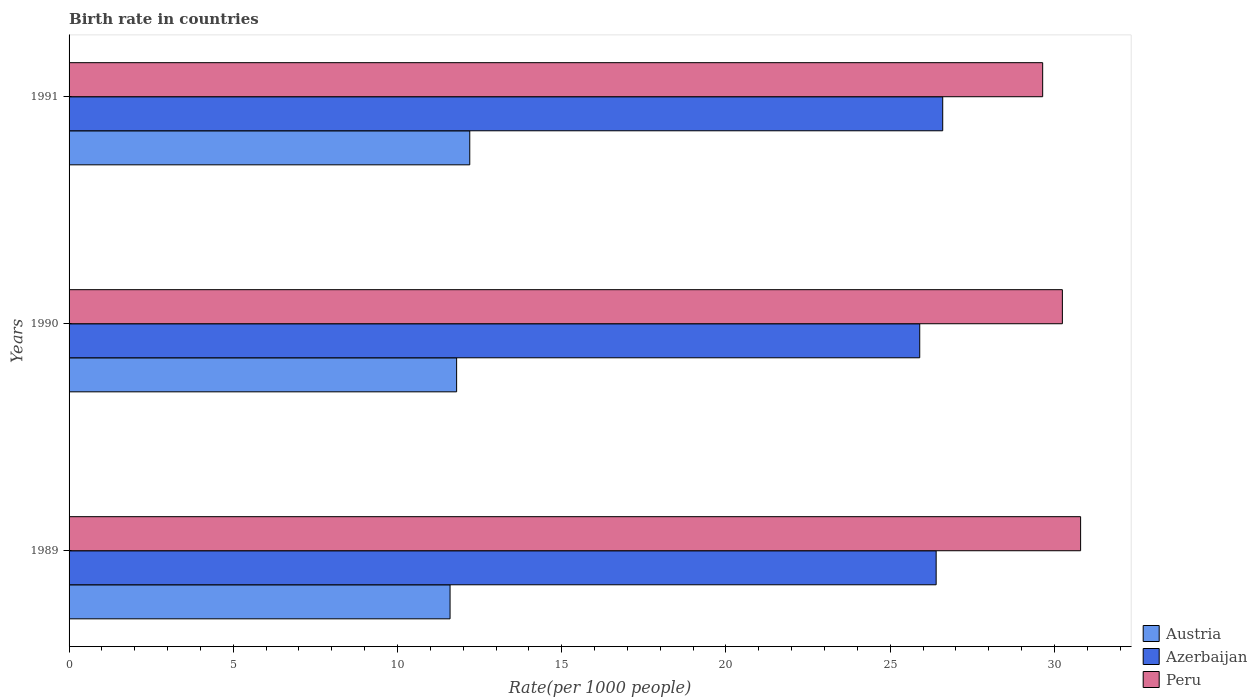How many different coloured bars are there?
Make the answer very short. 3. Are the number of bars per tick equal to the number of legend labels?
Offer a very short reply. Yes. How many bars are there on the 1st tick from the top?
Give a very brief answer. 3. How many bars are there on the 1st tick from the bottom?
Provide a short and direct response. 3. What is the label of the 1st group of bars from the top?
Your answer should be very brief. 1991. Across all years, what is the maximum birth rate in Peru?
Your response must be concise. 30.8. Across all years, what is the minimum birth rate in Azerbaijan?
Your answer should be very brief. 25.9. What is the total birth rate in Azerbaijan in the graph?
Keep it short and to the point. 78.9. What is the difference between the birth rate in Peru in 1990 and that in 1991?
Provide a succinct answer. 0.6. What is the difference between the birth rate in Azerbaijan in 1990 and the birth rate in Austria in 1991?
Provide a succinct answer. 13.7. What is the average birth rate in Austria per year?
Provide a short and direct response. 11.87. In the year 1990, what is the difference between the birth rate in Peru and birth rate in Azerbaijan?
Your answer should be very brief. 4.34. What is the ratio of the birth rate in Azerbaijan in 1989 to that in 1990?
Offer a terse response. 1.02. What is the difference between the highest and the second highest birth rate in Azerbaijan?
Your answer should be compact. 0.2. What is the difference between the highest and the lowest birth rate in Peru?
Provide a short and direct response. 1.15. Is the sum of the birth rate in Peru in 1989 and 1991 greater than the maximum birth rate in Azerbaijan across all years?
Your answer should be compact. Yes. Is it the case that in every year, the sum of the birth rate in Peru and birth rate in Austria is greater than the birth rate in Azerbaijan?
Your response must be concise. Yes. How many bars are there?
Provide a succinct answer. 9. Are all the bars in the graph horizontal?
Your answer should be very brief. Yes. What is the difference between two consecutive major ticks on the X-axis?
Your answer should be very brief. 5. Does the graph contain any zero values?
Your response must be concise. No. What is the title of the graph?
Offer a very short reply. Birth rate in countries. What is the label or title of the X-axis?
Your answer should be very brief. Rate(per 1000 people). What is the label or title of the Y-axis?
Your answer should be compact. Years. What is the Rate(per 1000 people) in Azerbaijan in 1989?
Provide a short and direct response. 26.4. What is the Rate(per 1000 people) of Peru in 1989?
Make the answer very short. 30.8. What is the Rate(per 1000 people) in Azerbaijan in 1990?
Give a very brief answer. 25.9. What is the Rate(per 1000 people) of Peru in 1990?
Offer a terse response. 30.24. What is the Rate(per 1000 people) in Austria in 1991?
Give a very brief answer. 12.2. What is the Rate(per 1000 people) in Azerbaijan in 1991?
Ensure brevity in your answer.  26.6. What is the Rate(per 1000 people) in Peru in 1991?
Make the answer very short. 29.64. Across all years, what is the maximum Rate(per 1000 people) of Austria?
Give a very brief answer. 12.2. Across all years, what is the maximum Rate(per 1000 people) in Azerbaijan?
Offer a terse response. 26.6. Across all years, what is the maximum Rate(per 1000 people) in Peru?
Provide a succinct answer. 30.8. Across all years, what is the minimum Rate(per 1000 people) of Azerbaijan?
Your answer should be very brief. 25.9. Across all years, what is the minimum Rate(per 1000 people) of Peru?
Your answer should be very brief. 29.64. What is the total Rate(per 1000 people) of Austria in the graph?
Your answer should be very brief. 35.6. What is the total Rate(per 1000 people) in Azerbaijan in the graph?
Provide a succinct answer. 78.9. What is the total Rate(per 1000 people) of Peru in the graph?
Your response must be concise. 90.68. What is the difference between the Rate(per 1000 people) in Austria in 1989 and that in 1990?
Give a very brief answer. -0.2. What is the difference between the Rate(per 1000 people) of Peru in 1989 and that in 1990?
Your response must be concise. 0.56. What is the difference between the Rate(per 1000 people) of Austria in 1989 and that in 1991?
Provide a short and direct response. -0.6. What is the difference between the Rate(per 1000 people) of Peru in 1989 and that in 1991?
Give a very brief answer. 1.16. What is the difference between the Rate(per 1000 people) of Azerbaijan in 1990 and that in 1991?
Ensure brevity in your answer.  -0.7. What is the difference between the Rate(per 1000 people) of Peru in 1990 and that in 1991?
Ensure brevity in your answer.  0.6. What is the difference between the Rate(per 1000 people) of Austria in 1989 and the Rate(per 1000 people) of Azerbaijan in 1990?
Your response must be concise. -14.3. What is the difference between the Rate(per 1000 people) in Austria in 1989 and the Rate(per 1000 people) in Peru in 1990?
Make the answer very short. -18.64. What is the difference between the Rate(per 1000 people) in Azerbaijan in 1989 and the Rate(per 1000 people) in Peru in 1990?
Your answer should be very brief. -3.84. What is the difference between the Rate(per 1000 people) in Austria in 1989 and the Rate(per 1000 people) in Azerbaijan in 1991?
Offer a very short reply. -15. What is the difference between the Rate(per 1000 people) of Austria in 1989 and the Rate(per 1000 people) of Peru in 1991?
Provide a succinct answer. -18.04. What is the difference between the Rate(per 1000 people) of Azerbaijan in 1989 and the Rate(per 1000 people) of Peru in 1991?
Make the answer very short. -3.24. What is the difference between the Rate(per 1000 people) of Austria in 1990 and the Rate(per 1000 people) of Azerbaijan in 1991?
Ensure brevity in your answer.  -14.8. What is the difference between the Rate(per 1000 people) of Austria in 1990 and the Rate(per 1000 people) of Peru in 1991?
Offer a very short reply. -17.84. What is the difference between the Rate(per 1000 people) in Azerbaijan in 1990 and the Rate(per 1000 people) in Peru in 1991?
Ensure brevity in your answer.  -3.74. What is the average Rate(per 1000 people) of Austria per year?
Give a very brief answer. 11.87. What is the average Rate(per 1000 people) of Azerbaijan per year?
Give a very brief answer. 26.3. What is the average Rate(per 1000 people) in Peru per year?
Make the answer very short. 30.23. In the year 1989, what is the difference between the Rate(per 1000 people) of Austria and Rate(per 1000 people) of Azerbaijan?
Provide a succinct answer. -14.8. In the year 1989, what is the difference between the Rate(per 1000 people) in Austria and Rate(per 1000 people) in Peru?
Keep it short and to the point. -19.2. In the year 1989, what is the difference between the Rate(per 1000 people) in Azerbaijan and Rate(per 1000 people) in Peru?
Make the answer very short. -4.4. In the year 1990, what is the difference between the Rate(per 1000 people) in Austria and Rate(per 1000 people) in Azerbaijan?
Your answer should be very brief. -14.1. In the year 1990, what is the difference between the Rate(per 1000 people) in Austria and Rate(per 1000 people) in Peru?
Give a very brief answer. -18.44. In the year 1990, what is the difference between the Rate(per 1000 people) in Azerbaijan and Rate(per 1000 people) in Peru?
Provide a short and direct response. -4.34. In the year 1991, what is the difference between the Rate(per 1000 people) of Austria and Rate(per 1000 people) of Azerbaijan?
Make the answer very short. -14.4. In the year 1991, what is the difference between the Rate(per 1000 people) in Austria and Rate(per 1000 people) in Peru?
Offer a terse response. -17.44. In the year 1991, what is the difference between the Rate(per 1000 people) in Azerbaijan and Rate(per 1000 people) in Peru?
Keep it short and to the point. -3.04. What is the ratio of the Rate(per 1000 people) of Austria in 1989 to that in 1990?
Offer a terse response. 0.98. What is the ratio of the Rate(per 1000 people) of Azerbaijan in 1989 to that in 1990?
Offer a very short reply. 1.02. What is the ratio of the Rate(per 1000 people) in Peru in 1989 to that in 1990?
Your response must be concise. 1.02. What is the ratio of the Rate(per 1000 people) of Austria in 1989 to that in 1991?
Give a very brief answer. 0.95. What is the ratio of the Rate(per 1000 people) of Peru in 1989 to that in 1991?
Your response must be concise. 1.04. What is the ratio of the Rate(per 1000 people) of Austria in 1990 to that in 1991?
Your response must be concise. 0.97. What is the ratio of the Rate(per 1000 people) in Azerbaijan in 1990 to that in 1991?
Offer a very short reply. 0.97. What is the ratio of the Rate(per 1000 people) in Peru in 1990 to that in 1991?
Give a very brief answer. 1.02. What is the difference between the highest and the second highest Rate(per 1000 people) in Austria?
Offer a terse response. 0.4. What is the difference between the highest and the second highest Rate(per 1000 people) of Azerbaijan?
Offer a very short reply. 0.2. What is the difference between the highest and the second highest Rate(per 1000 people) in Peru?
Provide a succinct answer. 0.56. What is the difference between the highest and the lowest Rate(per 1000 people) in Austria?
Make the answer very short. 0.6. What is the difference between the highest and the lowest Rate(per 1000 people) of Peru?
Ensure brevity in your answer.  1.16. 